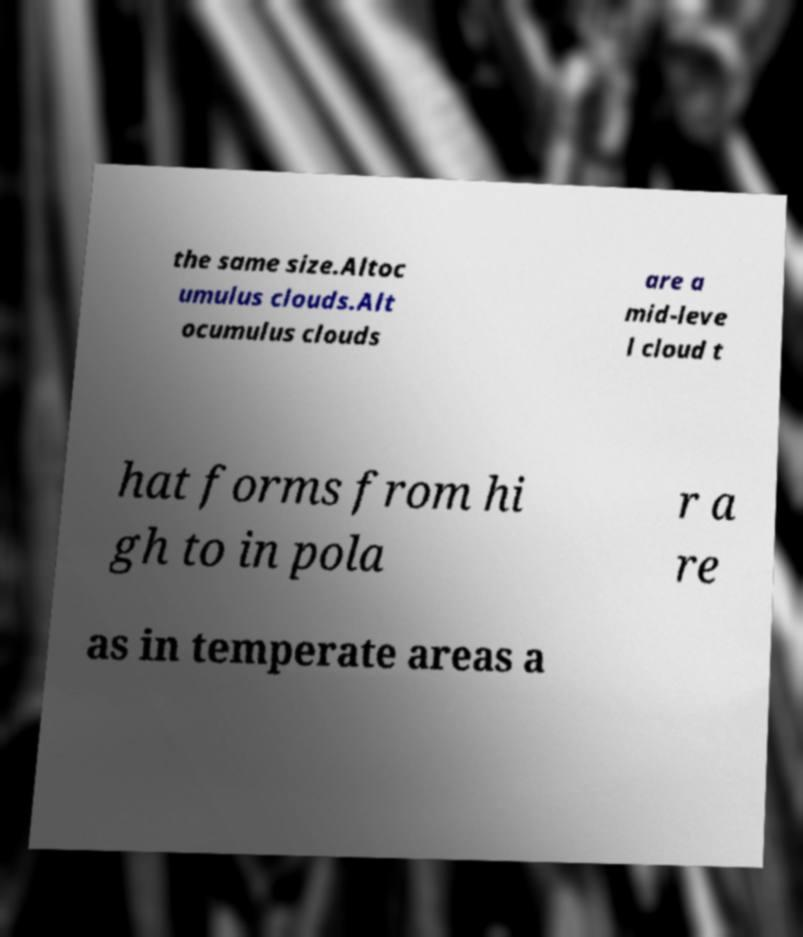What messages or text are displayed in this image? I need them in a readable, typed format. the same size.Altoc umulus clouds.Alt ocumulus clouds are a mid-leve l cloud t hat forms from hi gh to in pola r a re as in temperate areas a 